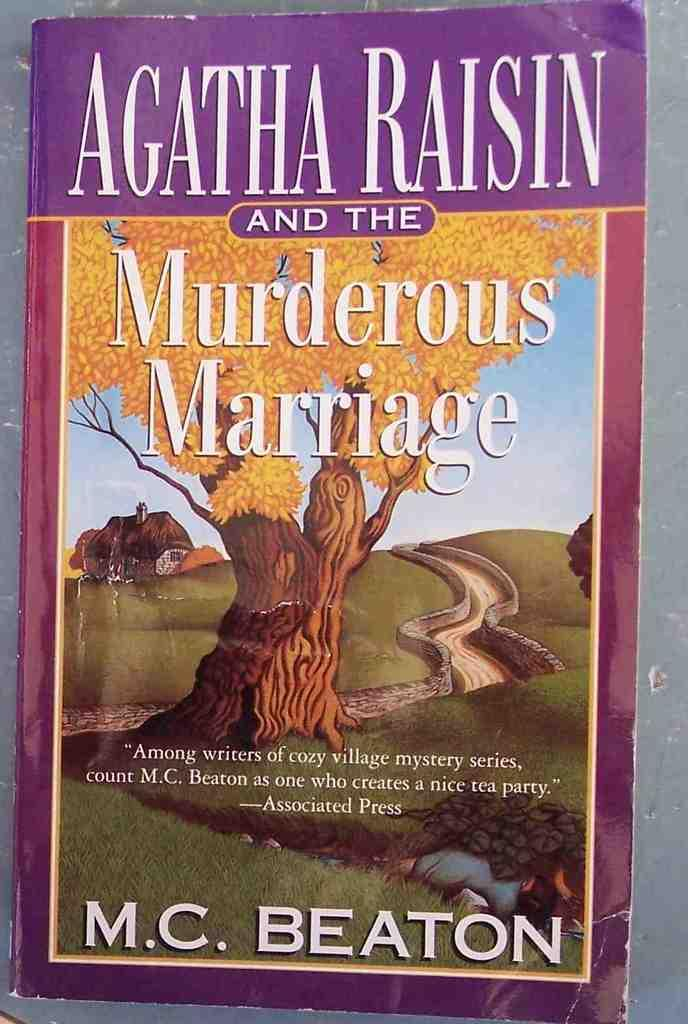<image>
Share a concise interpretation of the image provided. The cover of a fictional book about marriage. 